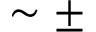Convert formula to latex. <formula><loc_0><loc_0><loc_500><loc_500>\sim \pm</formula> 